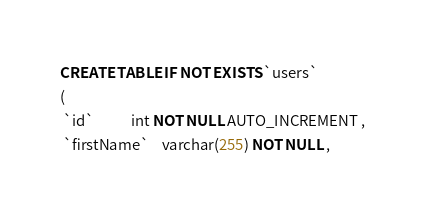Convert code to text. <code><loc_0><loc_0><loc_500><loc_500><_SQL_>CREATE TABLE IF NOT EXISTS `users`
(
 `id`           int NOT NULL AUTO_INCREMENT ,
 `firstName`    varchar(255) NOT NULL ,</code> 